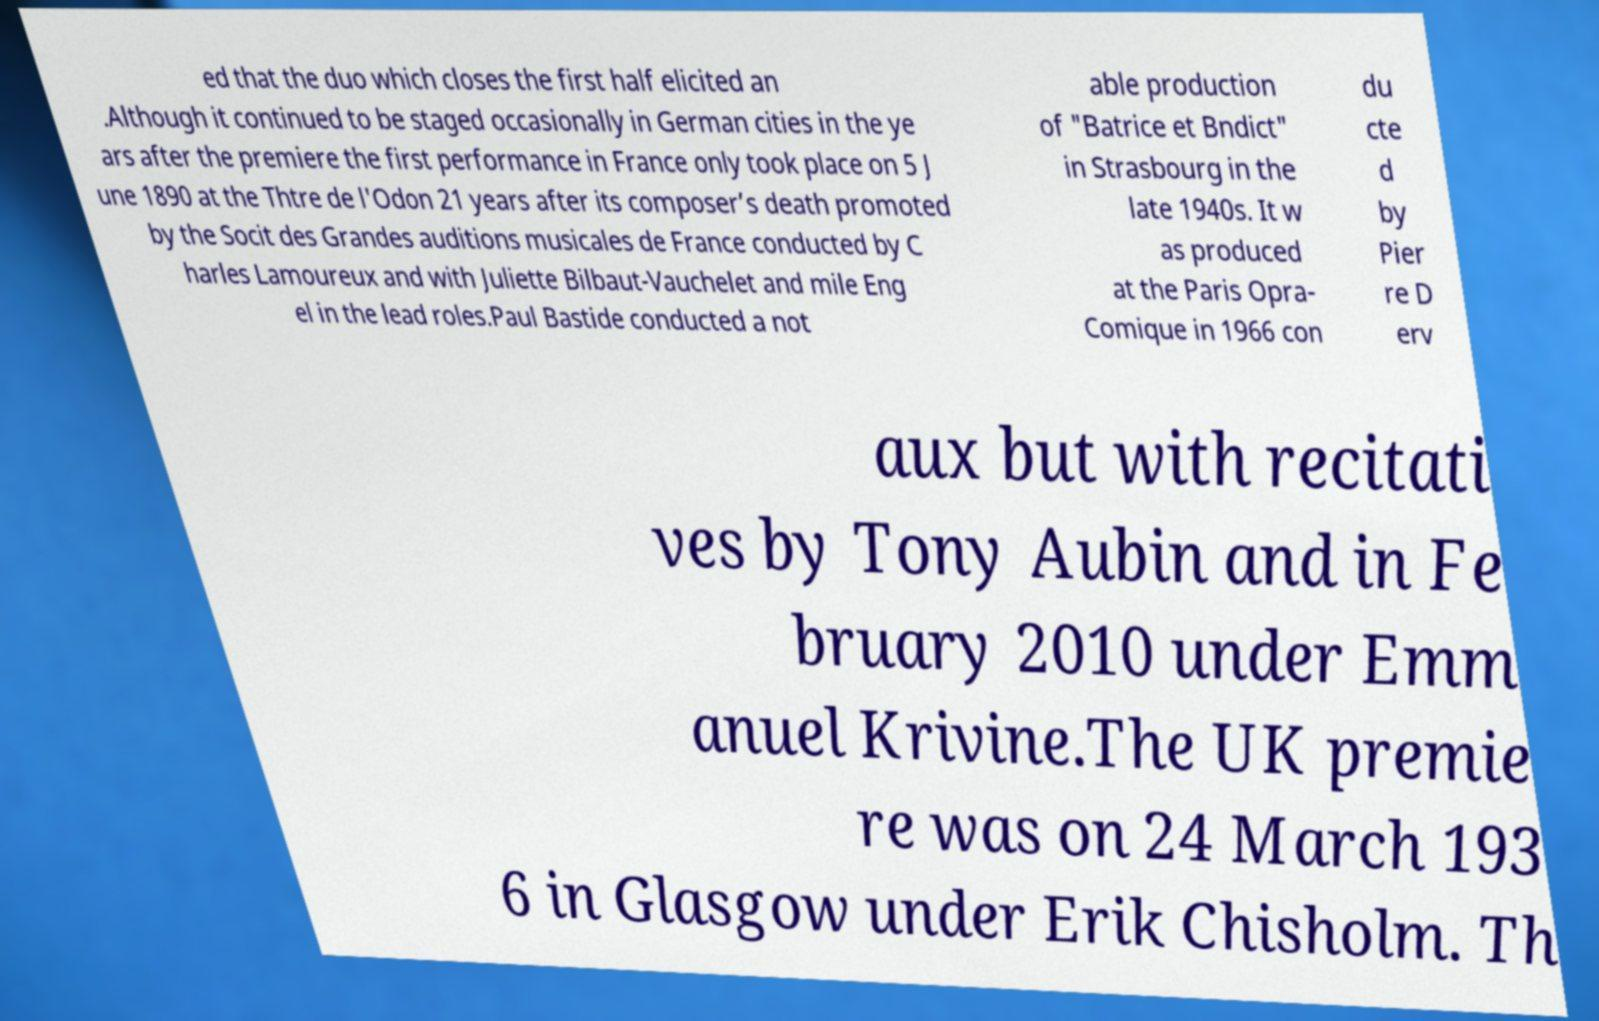What messages or text are displayed in this image? I need them in a readable, typed format. ed that the duo which closes the first half elicited an .Although it continued to be staged occasionally in German cities in the ye ars after the premiere the first performance in France only took place on 5 J une 1890 at the Thtre de l'Odon 21 years after its composer’s death promoted by the Socit des Grandes auditions musicales de France conducted by C harles Lamoureux and with Juliette Bilbaut-Vauchelet and mile Eng el in the lead roles.Paul Bastide conducted a not able production of "Batrice et Bndict" in Strasbourg in the late 1940s. It w as produced at the Paris Opra- Comique in 1966 con du cte d by Pier re D erv aux but with recitati ves by Tony Aubin and in Fe bruary 2010 under Emm anuel Krivine.The UK premie re was on 24 March 193 6 in Glasgow under Erik Chisholm. Th 